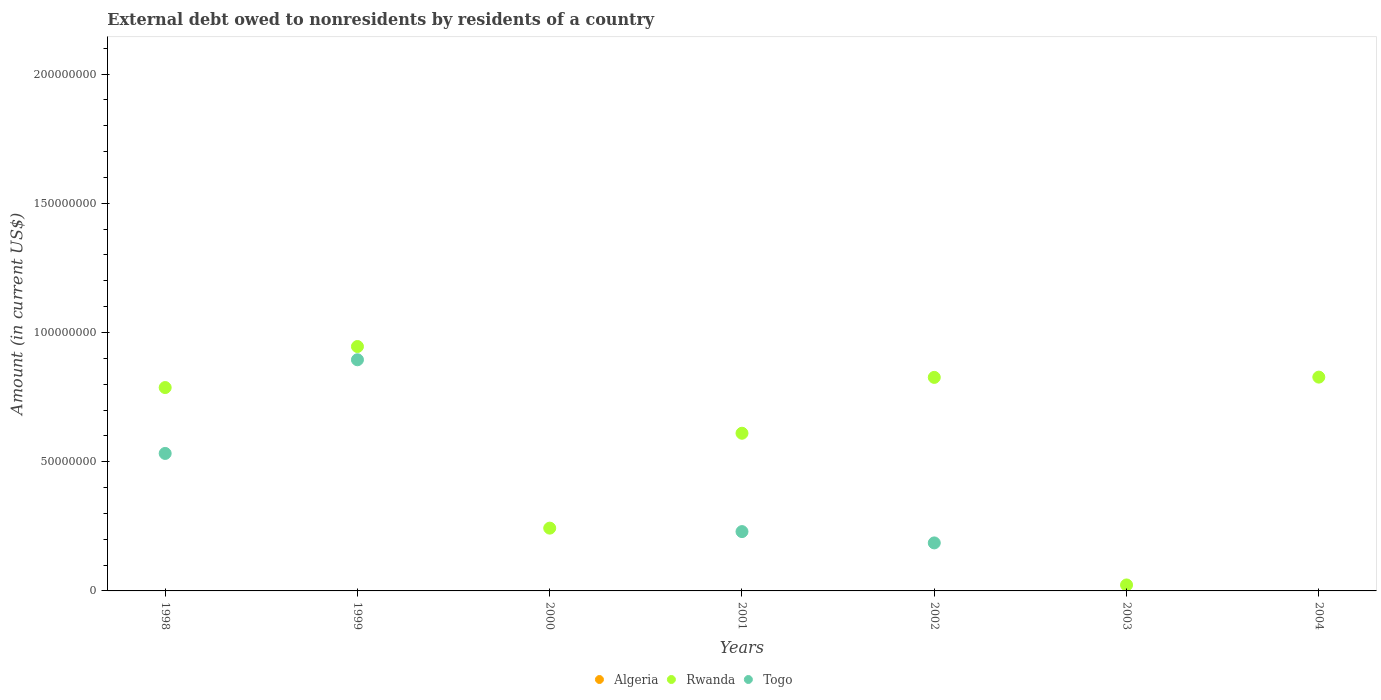How many different coloured dotlines are there?
Your answer should be compact. 2. What is the external debt owed by residents in Togo in 2001?
Ensure brevity in your answer.  2.30e+07. Across all years, what is the maximum external debt owed by residents in Togo?
Give a very brief answer. 8.94e+07. In which year was the external debt owed by residents in Rwanda maximum?
Your answer should be compact. 1999. What is the total external debt owed by residents in Togo in the graph?
Your response must be concise. 1.84e+08. What is the difference between the external debt owed by residents in Rwanda in 2001 and that in 2004?
Provide a short and direct response. -2.17e+07. What is the difference between the external debt owed by residents in Algeria in 1998 and the external debt owed by residents in Togo in 2001?
Offer a very short reply. -2.30e+07. In the year 1998, what is the difference between the external debt owed by residents in Rwanda and external debt owed by residents in Togo?
Your answer should be very brief. 2.55e+07. In how many years, is the external debt owed by residents in Algeria greater than 100000000 US$?
Make the answer very short. 0. What is the ratio of the external debt owed by residents in Rwanda in 2001 to that in 2002?
Keep it short and to the point. 0.74. Is the difference between the external debt owed by residents in Rwanda in 1998 and 1999 greater than the difference between the external debt owed by residents in Togo in 1998 and 1999?
Your answer should be compact. Yes. What is the difference between the highest and the second highest external debt owed by residents in Rwanda?
Provide a short and direct response. 1.18e+07. In how many years, is the external debt owed by residents in Togo greater than the average external debt owed by residents in Togo taken over all years?
Provide a succinct answer. 2. Is the sum of the external debt owed by residents in Rwanda in 1998 and 2003 greater than the maximum external debt owed by residents in Algeria across all years?
Keep it short and to the point. Yes. Is it the case that in every year, the sum of the external debt owed by residents in Rwanda and external debt owed by residents in Togo  is greater than the external debt owed by residents in Algeria?
Keep it short and to the point. Yes. Is the external debt owed by residents in Rwanda strictly greater than the external debt owed by residents in Togo over the years?
Give a very brief answer. Yes. How many dotlines are there?
Provide a short and direct response. 2. What is the difference between two consecutive major ticks on the Y-axis?
Your answer should be compact. 5.00e+07. Are the values on the major ticks of Y-axis written in scientific E-notation?
Provide a succinct answer. No. Does the graph contain any zero values?
Provide a short and direct response. Yes. What is the title of the graph?
Ensure brevity in your answer.  External debt owed to nonresidents by residents of a country. What is the label or title of the Y-axis?
Provide a succinct answer. Amount (in current US$). What is the Amount (in current US$) of Rwanda in 1998?
Your response must be concise. 7.87e+07. What is the Amount (in current US$) of Togo in 1998?
Give a very brief answer. 5.32e+07. What is the Amount (in current US$) in Rwanda in 1999?
Keep it short and to the point. 9.46e+07. What is the Amount (in current US$) in Togo in 1999?
Offer a terse response. 8.94e+07. What is the Amount (in current US$) of Rwanda in 2000?
Provide a short and direct response. 2.43e+07. What is the Amount (in current US$) in Rwanda in 2001?
Your answer should be very brief. 6.10e+07. What is the Amount (in current US$) of Togo in 2001?
Give a very brief answer. 2.30e+07. What is the Amount (in current US$) in Rwanda in 2002?
Give a very brief answer. 8.26e+07. What is the Amount (in current US$) in Togo in 2002?
Your answer should be very brief. 1.86e+07. What is the Amount (in current US$) of Algeria in 2003?
Your response must be concise. 0. What is the Amount (in current US$) of Rwanda in 2003?
Your answer should be very brief. 2.32e+06. What is the Amount (in current US$) of Algeria in 2004?
Provide a short and direct response. 0. What is the Amount (in current US$) of Rwanda in 2004?
Your answer should be compact. 8.27e+07. What is the Amount (in current US$) in Togo in 2004?
Keep it short and to the point. 0. Across all years, what is the maximum Amount (in current US$) in Rwanda?
Keep it short and to the point. 9.46e+07. Across all years, what is the maximum Amount (in current US$) of Togo?
Provide a short and direct response. 8.94e+07. Across all years, what is the minimum Amount (in current US$) in Rwanda?
Provide a short and direct response. 2.32e+06. What is the total Amount (in current US$) in Algeria in the graph?
Keep it short and to the point. 0. What is the total Amount (in current US$) of Rwanda in the graph?
Your response must be concise. 4.26e+08. What is the total Amount (in current US$) in Togo in the graph?
Your answer should be compact. 1.84e+08. What is the difference between the Amount (in current US$) in Rwanda in 1998 and that in 1999?
Your answer should be compact. -1.59e+07. What is the difference between the Amount (in current US$) of Togo in 1998 and that in 1999?
Offer a terse response. -3.62e+07. What is the difference between the Amount (in current US$) of Rwanda in 1998 and that in 2000?
Your answer should be compact. 5.44e+07. What is the difference between the Amount (in current US$) in Rwanda in 1998 and that in 2001?
Your response must be concise. 1.77e+07. What is the difference between the Amount (in current US$) in Togo in 1998 and that in 2001?
Your answer should be compact. 3.02e+07. What is the difference between the Amount (in current US$) in Rwanda in 1998 and that in 2002?
Your response must be concise. -3.93e+06. What is the difference between the Amount (in current US$) in Togo in 1998 and that in 2002?
Provide a short and direct response. 3.46e+07. What is the difference between the Amount (in current US$) in Rwanda in 1998 and that in 2003?
Offer a terse response. 7.64e+07. What is the difference between the Amount (in current US$) in Rwanda in 1998 and that in 2004?
Provide a short and direct response. -4.04e+06. What is the difference between the Amount (in current US$) in Rwanda in 1999 and that in 2000?
Offer a terse response. 7.03e+07. What is the difference between the Amount (in current US$) of Rwanda in 1999 and that in 2001?
Make the answer very short. 3.36e+07. What is the difference between the Amount (in current US$) of Togo in 1999 and that in 2001?
Your response must be concise. 6.65e+07. What is the difference between the Amount (in current US$) in Rwanda in 1999 and that in 2002?
Provide a succinct answer. 1.19e+07. What is the difference between the Amount (in current US$) in Togo in 1999 and that in 2002?
Make the answer very short. 7.09e+07. What is the difference between the Amount (in current US$) of Rwanda in 1999 and that in 2003?
Make the answer very short. 9.23e+07. What is the difference between the Amount (in current US$) of Rwanda in 1999 and that in 2004?
Offer a terse response. 1.18e+07. What is the difference between the Amount (in current US$) of Rwanda in 2000 and that in 2001?
Provide a short and direct response. -3.67e+07. What is the difference between the Amount (in current US$) of Rwanda in 2000 and that in 2002?
Provide a short and direct response. -5.83e+07. What is the difference between the Amount (in current US$) in Rwanda in 2000 and that in 2003?
Keep it short and to the point. 2.20e+07. What is the difference between the Amount (in current US$) in Rwanda in 2000 and that in 2004?
Your answer should be very brief. -5.84e+07. What is the difference between the Amount (in current US$) in Rwanda in 2001 and that in 2002?
Keep it short and to the point. -2.16e+07. What is the difference between the Amount (in current US$) in Togo in 2001 and that in 2002?
Provide a short and direct response. 4.37e+06. What is the difference between the Amount (in current US$) of Rwanda in 2001 and that in 2003?
Your response must be concise. 5.87e+07. What is the difference between the Amount (in current US$) of Rwanda in 2001 and that in 2004?
Provide a short and direct response. -2.17e+07. What is the difference between the Amount (in current US$) of Rwanda in 2002 and that in 2003?
Make the answer very short. 8.03e+07. What is the difference between the Amount (in current US$) in Rwanda in 2002 and that in 2004?
Provide a succinct answer. -1.05e+05. What is the difference between the Amount (in current US$) in Rwanda in 2003 and that in 2004?
Provide a succinct answer. -8.04e+07. What is the difference between the Amount (in current US$) in Rwanda in 1998 and the Amount (in current US$) in Togo in 1999?
Provide a short and direct response. -1.08e+07. What is the difference between the Amount (in current US$) of Rwanda in 1998 and the Amount (in current US$) of Togo in 2001?
Ensure brevity in your answer.  5.57e+07. What is the difference between the Amount (in current US$) in Rwanda in 1998 and the Amount (in current US$) in Togo in 2002?
Provide a succinct answer. 6.01e+07. What is the difference between the Amount (in current US$) of Rwanda in 1999 and the Amount (in current US$) of Togo in 2001?
Your answer should be very brief. 7.16e+07. What is the difference between the Amount (in current US$) in Rwanda in 1999 and the Amount (in current US$) in Togo in 2002?
Offer a terse response. 7.60e+07. What is the difference between the Amount (in current US$) in Rwanda in 2000 and the Amount (in current US$) in Togo in 2001?
Give a very brief answer. 1.34e+06. What is the difference between the Amount (in current US$) in Rwanda in 2000 and the Amount (in current US$) in Togo in 2002?
Your answer should be very brief. 5.72e+06. What is the difference between the Amount (in current US$) in Rwanda in 2001 and the Amount (in current US$) in Togo in 2002?
Offer a terse response. 4.24e+07. What is the average Amount (in current US$) of Algeria per year?
Provide a succinct answer. 0. What is the average Amount (in current US$) in Rwanda per year?
Offer a terse response. 6.09e+07. What is the average Amount (in current US$) in Togo per year?
Make the answer very short. 2.63e+07. In the year 1998, what is the difference between the Amount (in current US$) in Rwanda and Amount (in current US$) in Togo?
Make the answer very short. 2.55e+07. In the year 1999, what is the difference between the Amount (in current US$) in Rwanda and Amount (in current US$) in Togo?
Make the answer very short. 5.13e+06. In the year 2001, what is the difference between the Amount (in current US$) of Rwanda and Amount (in current US$) of Togo?
Your answer should be very brief. 3.81e+07. In the year 2002, what is the difference between the Amount (in current US$) in Rwanda and Amount (in current US$) in Togo?
Give a very brief answer. 6.40e+07. What is the ratio of the Amount (in current US$) in Rwanda in 1998 to that in 1999?
Offer a terse response. 0.83. What is the ratio of the Amount (in current US$) of Togo in 1998 to that in 1999?
Keep it short and to the point. 0.59. What is the ratio of the Amount (in current US$) of Rwanda in 1998 to that in 2000?
Give a very brief answer. 3.24. What is the ratio of the Amount (in current US$) in Rwanda in 1998 to that in 2001?
Your response must be concise. 1.29. What is the ratio of the Amount (in current US$) in Togo in 1998 to that in 2001?
Keep it short and to the point. 2.32. What is the ratio of the Amount (in current US$) in Rwanda in 1998 to that in 2002?
Your answer should be compact. 0.95. What is the ratio of the Amount (in current US$) in Togo in 1998 to that in 2002?
Your answer should be very brief. 2.86. What is the ratio of the Amount (in current US$) of Rwanda in 1998 to that in 2003?
Offer a very short reply. 33.99. What is the ratio of the Amount (in current US$) of Rwanda in 1998 to that in 2004?
Offer a very short reply. 0.95. What is the ratio of the Amount (in current US$) in Rwanda in 1999 to that in 2000?
Ensure brevity in your answer.  3.89. What is the ratio of the Amount (in current US$) in Rwanda in 1999 to that in 2001?
Make the answer very short. 1.55. What is the ratio of the Amount (in current US$) of Togo in 1999 to that in 2001?
Offer a terse response. 3.9. What is the ratio of the Amount (in current US$) in Rwanda in 1999 to that in 2002?
Keep it short and to the point. 1.14. What is the ratio of the Amount (in current US$) of Togo in 1999 to that in 2002?
Your response must be concise. 4.81. What is the ratio of the Amount (in current US$) of Rwanda in 1999 to that in 2003?
Offer a terse response. 40.85. What is the ratio of the Amount (in current US$) in Rwanda in 1999 to that in 2004?
Provide a short and direct response. 1.14. What is the ratio of the Amount (in current US$) in Rwanda in 2000 to that in 2001?
Provide a short and direct response. 0.4. What is the ratio of the Amount (in current US$) in Rwanda in 2000 to that in 2002?
Ensure brevity in your answer.  0.29. What is the ratio of the Amount (in current US$) in Rwanda in 2000 to that in 2003?
Make the answer very short. 10.49. What is the ratio of the Amount (in current US$) of Rwanda in 2000 to that in 2004?
Offer a terse response. 0.29. What is the ratio of the Amount (in current US$) in Rwanda in 2001 to that in 2002?
Provide a short and direct response. 0.74. What is the ratio of the Amount (in current US$) in Togo in 2001 to that in 2002?
Provide a short and direct response. 1.24. What is the ratio of the Amount (in current US$) of Rwanda in 2001 to that in 2003?
Make the answer very short. 26.36. What is the ratio of the Amount (in current US$) in Rwanda in 2001 to that in 2004?
Your answer should be very brief. 0.74. What is the ratio of the Amount (in current US$) of Rwanda in 2002 to that in 2003?
Give a very brief answer. 35.69. What is the ratio of the Amount (in current US$) of Rwanda in 2003 to that in 2004?
Keep it short and to the point. 0.03. What is the difference between the highest and the second highest Amount (in current US$) of Rwanda?
Your answer should be very brief. 1.18e+07. What is the difference between the highest and the second highest Amount (in current US$) of Togo?
Provide a short and direct response. 3.62e+07. What is the difference between the highest and the lowest Amount (in current US$) of Rwanda?
Keep it short and to the point. 9.23e+07. What is the difference between the highest and the lowest Amount (in current US$) of Togo?
Ensure brevity in your answer.  8.94e+07. 